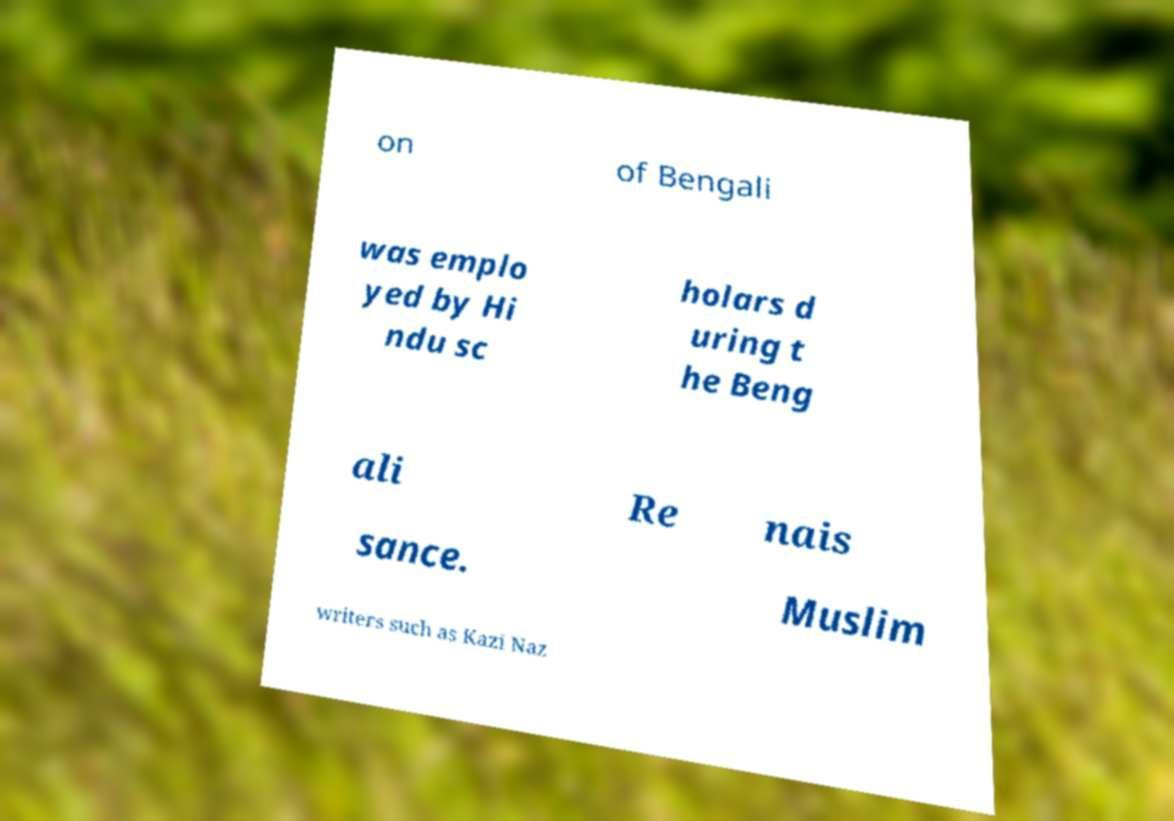I need the written content from this picture converted into text. Can you do that? on of Bengali was emplo yed by Hi ndu sc holars d uring t he Beng ali Re nais sance. Muslim writers such as Kazi Naz 